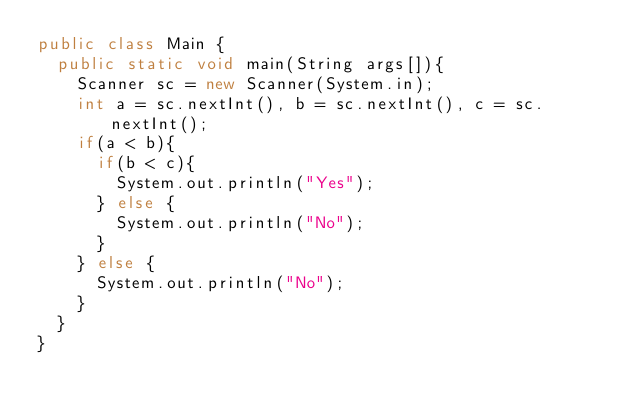<code> <loc_0><loc_0><loc_500><loc_500><_Java_>public class Main {
	public static void main(String args[]){
		Scanner sc = new Scanner(System.in);
		int a = sc.nextInt(), b = sc.nextInt(), c = sc.nextInt();
		if(a < b){
			if(b < c){
				System.out.println("Yes");
			} else {
				System.out.println("No");
			}
		} else {
			System.out.println("No");
		}
	}
}</code> 